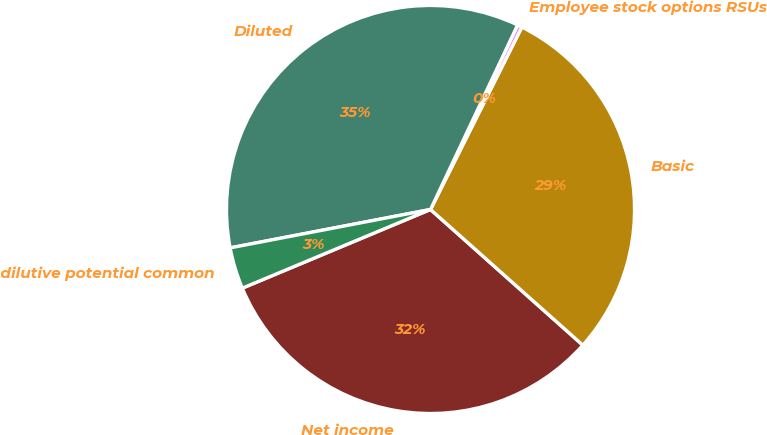Convert chart. <chart><loc_0><loc_0><loc_500><loc_500><pie_chart><fcel>Net income<fcel>Basic<fcel>Employee stock options RSUs<fcel>Diluted<fcel>Anti-dilutive potential common<nl><fcel>32.12%<fcel>29.2%<fcel>0.37%<fcel>35.04%<fcel>3.29%<nl></chart> 